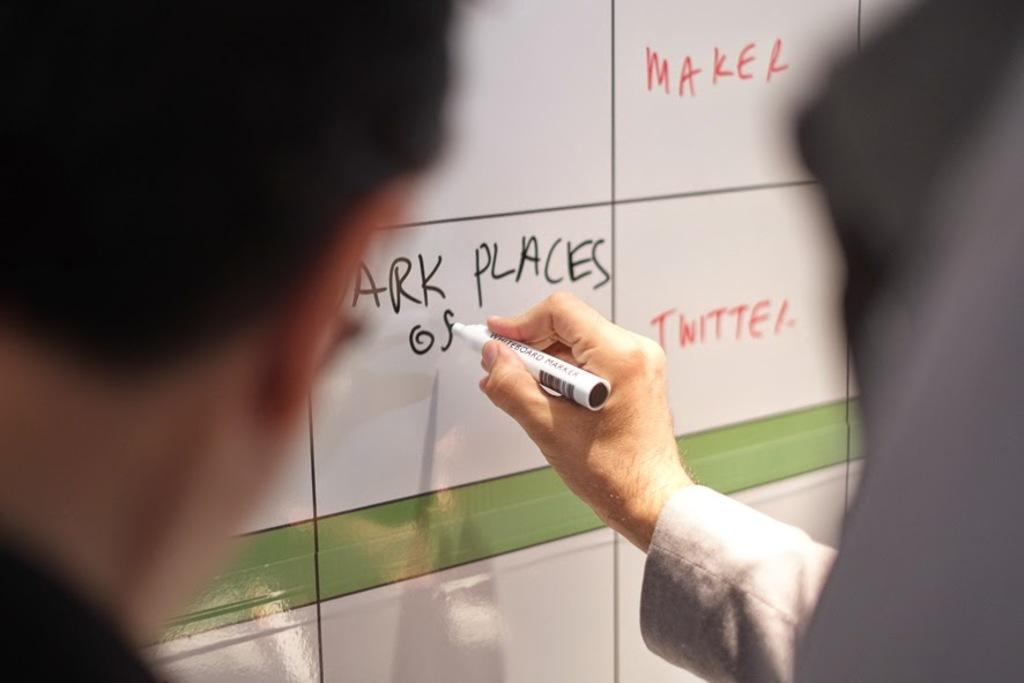What is the person in the image doing? The person is writing on a whiteboard. What tool is the person using to write on the whiteboard? The person is using a marker to write. What type of bird can be seen flying across the ground in the image? There is no bird present in the image; it only features a person writing on a whiteboard with a marker. 